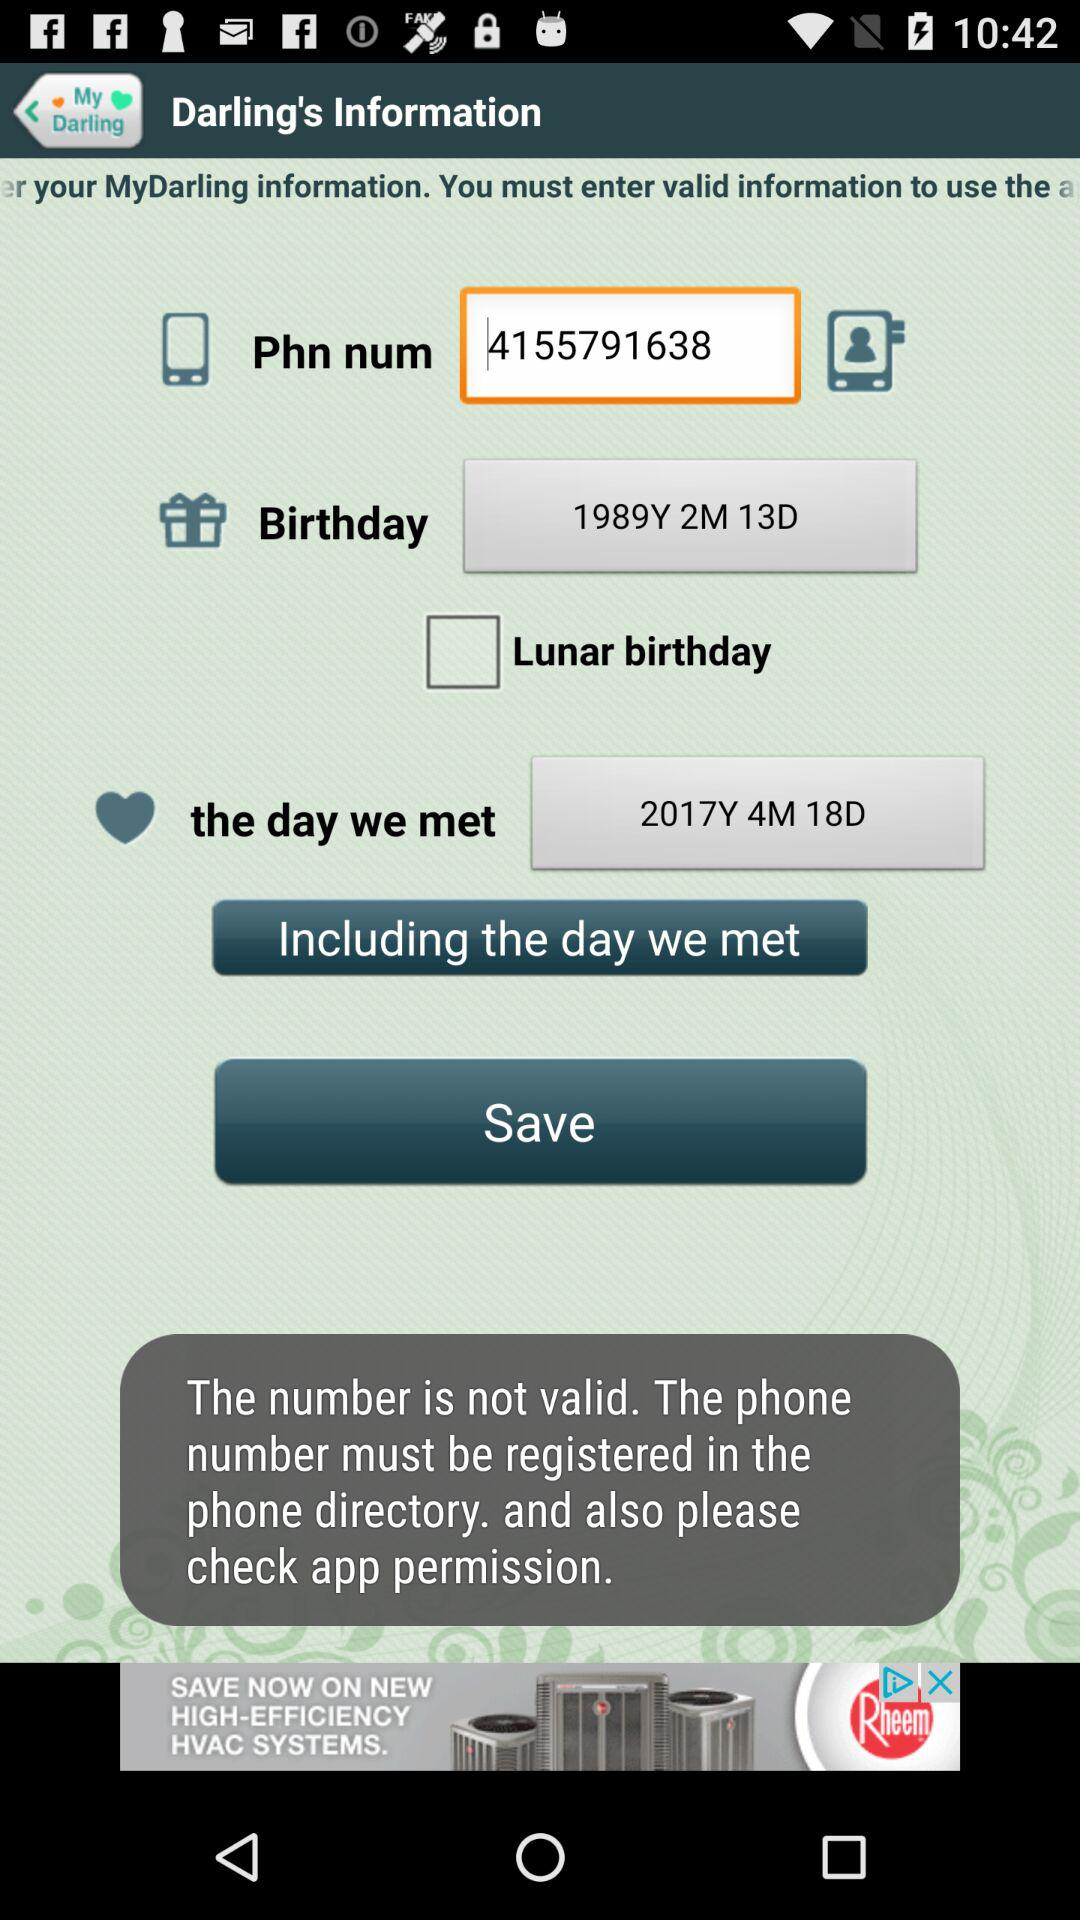What is the birthday date? The date of birth is February 13, 1989. 